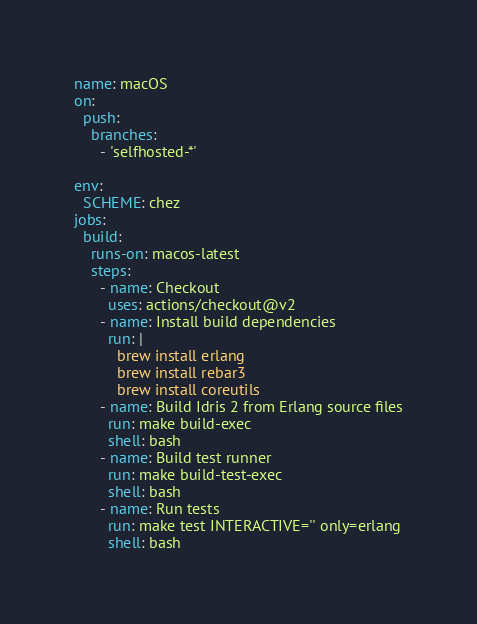Convert code to text. <code><loc_0><loc_0><loc_500><loc_500><_YAML_>name: macOS
on:
  push:
    branches:
      - 'selfhosted-*'

env:
  SCHEME: chez
jobs:
  build:
    runs-on: macos-latest
    steps:
      - name: Checkout
        uses: actions/checkout@v2
      - name: Install build dependencies
        run: |
          brew install erlang
          brew install rebar3
          brew install coreutils
      - name: Build Idris 2 from Erlang source files
        run: make build-exec
        shell: bash
      - name: Build test runner
        run: make build-test-exec
        shell: bash
      - name: Run tests
        run: make test INTERACTIVE='' only=erlang
        shell: bash
</code> 